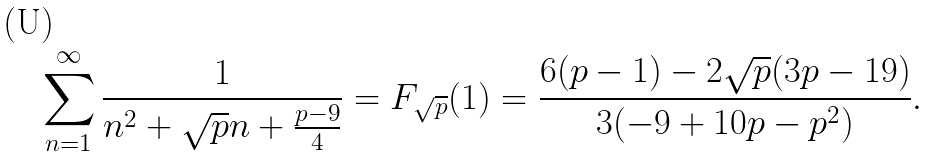<formula> <loc_0><loc_0><loc_500><loc_500>\sum _ { n = 1 } ^ { \infty } \frac { 1 } { n ^ { 2 } + \sqrt { p } n + \frac { p - 9 } { 4 } } = F _ { \sqrt { p } } ( 1 ) = \frac { 6 ( p - 1 ) - 2 \sqrt { p } ( 3 p - 1 9 ) } { 3 ( - 9 + 1 0 p - p ^ { 2 } ) } .</formula> 